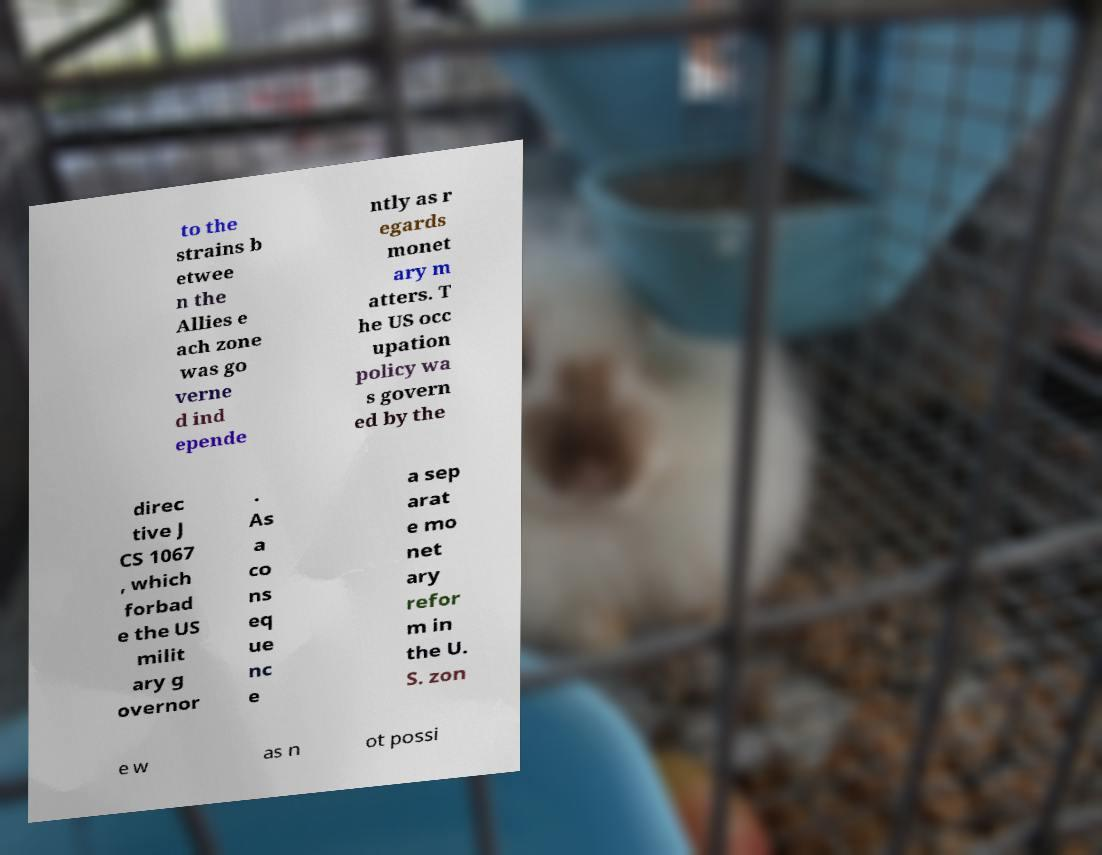What messages or text are displayed in this image? I need them in a readable, typed format. to the strains b etwee n the Allies e ach zone was go verne d ind epende ntly as r egards monet ary m atters. T he US occ upation policy wa s govern ed by the direc tive J CS 1067 , which forbad e the US milit ary g overnor . As a co ns eq ue nc e a sep arat e mo net ary refor m in the U. S. zon e w as n ot possi 